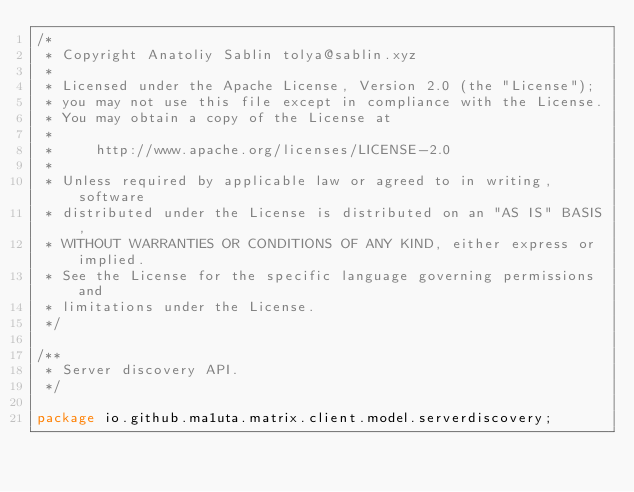Convert code to text. <code><loc_0><loc_0><loc_500><loc_500><_Java_>/*
 * Copyright Anatoliy Sablin tolya@sablin.xyz
 *
 * Licensed under the Apache License, Version 2.0 (the "License");
 * you may not use this file except in compliance with the License.
 * You may obtain a copy of the License at
 *
 *     http://www.apache.org/licenses/LICENSE-2.0
 *
 * Unless required by applicable law or agreed to in writing, software
 * distributed under the License is distributed on an "AS IS" BASIS,
 * WITHOUT WARRANTIES OR CONDITIONS OF ANY KIND, either express or implied.
 * See the License for the specific language governing permissions and
 * limitations under the License.
 */

/**
 * Server discovery API.
 */

package io.github.ma1uta.matrix.client.model.serverdiscovery;
</code> 